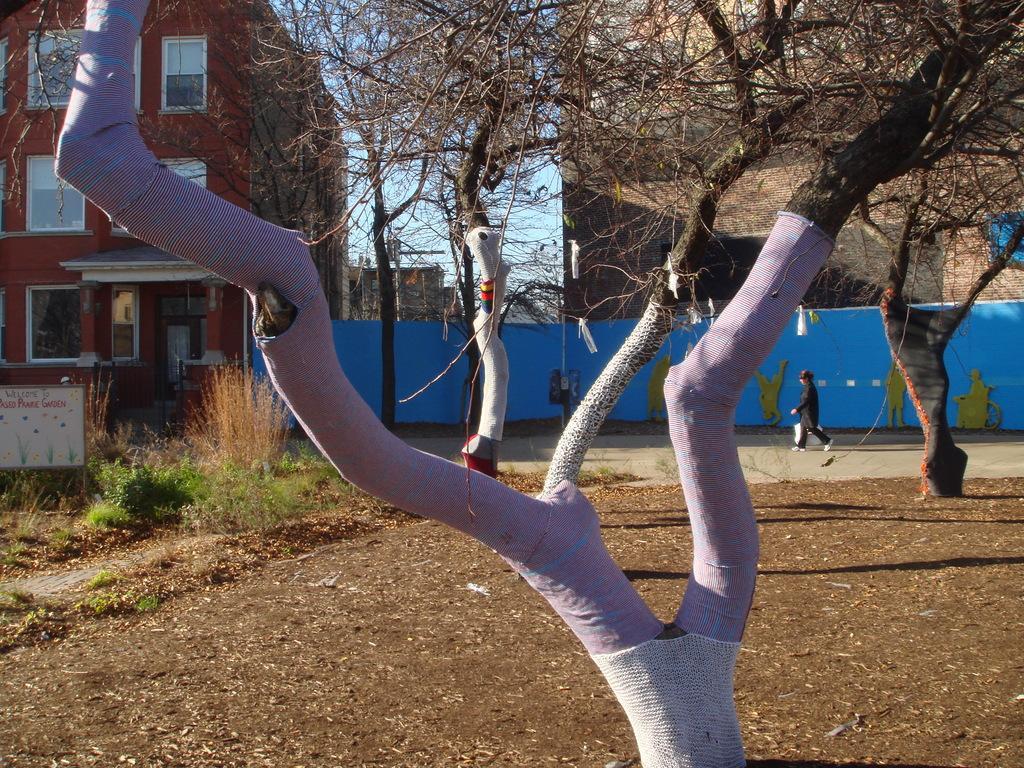Please provide a concise description of this image. In the center of the image we can see trees are there. In the background of the image we can see buildings, door, windows, boards and person are there. At the top of the image sky is there. At the bottom of the image we can see some plants, grass, board, ground are there. 